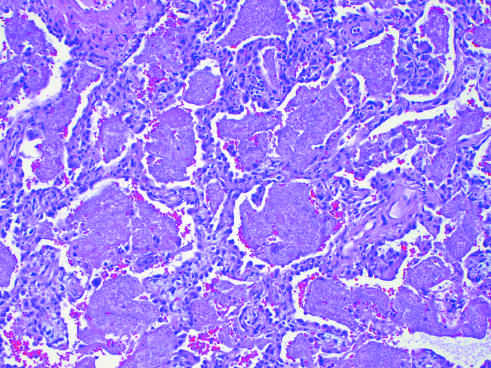what are the alveoli filled with?
Answer the question using a single word or phrase. A characteristic foamy acellular exudate 